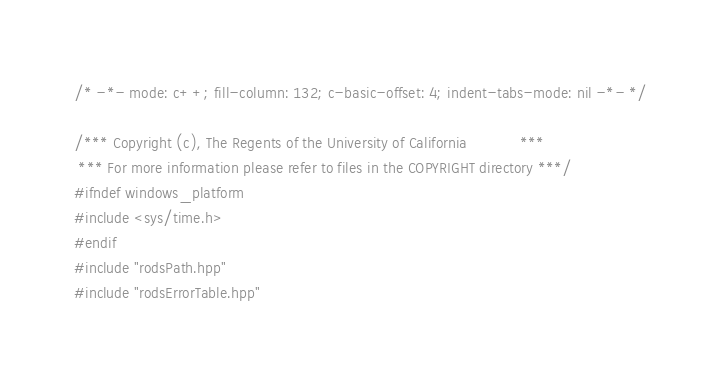Convert code to text. <code><loc_0><loc_0><loc_500><loc_500><_C++_>/* -*- mode: c++; fill-column: 132; c-basic-offset: 4; indent-tabs-mode: nil -*- */

/*** Copyright (c), The Regents of the University of California            ***
 *** For more information please refer to files in the COPYRIGHT directory ***/
#ifndef windows_platform
#include <sys/time.h>
#endif
#include "rodsPath.hpp"
#include "rodsErrorTable.hpp"</code> 